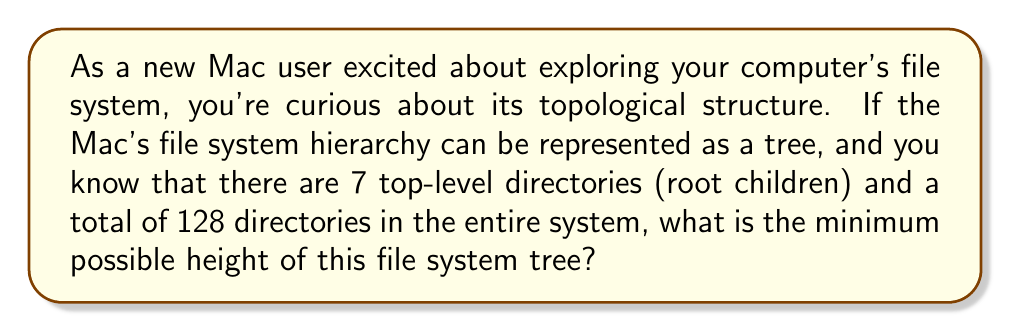Give your solution to this math problem. To solve this problem, let's approach it step-by-step using concepts from topology and graph theory:

1) In topology, a file system can be represented as a tree structure, where directories are nodes and the hierarchical relationships are edges.

2) We're given two key pieces of information:
   - There are 7 top-level directories (children of the root)
   - There are 128 total directories in the system

3) The height of a tree is defined as the number of edges in the longest path from the root to a leaf node.

4) To minimize the height, we need to distribute the directories as evenly as possible among the 7 top-level directories.

5) Let's calculate how many levels we need to accommodate all directories:
   - Level 0 (root): 1 directory
   - Level 1: 7 directories
   - Level 2: At most $7 * 7 = 49$ new directories
   - Level 3: At most $7 * 49 = 343$ new directories

6) Let's sum up the directories:
   $1 + 7 + 49 = 57$ directories up to level 2
   $57 + 343 = 400$ directories up to level 3

7) We only need 128 directories in total, so we don't need to go to level 3. However, we need more than level 2 can provide.

8) The minimum height will be achieved when we use just enough of level 3 to reach 128 directories.

9) We need $128 - 57 = 71$ additional directories at level 3.

10) Therefore, the minimum height of the tree is 3.

This topology ensures that we have the required 128 directories while keeping the tree as shallow as possible, given the constraint of 7 top-level directories.
Answer: The minimum possible height of the Mac's file system tree is 3. 